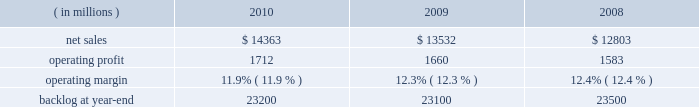Operating profit for the segment increased 10% ( 10 % ) in 2009 compared to 2008 .
The growth in operating profit primarily was due to increases in air mobility and other aeronautics programs .
The $ 70 million increase in air mobility 2019s operating profit primarily was due to the higher volume on c-130j deliveries and c-130 support programs .
In other aeronautics programs , operating profit increased $ 120 million , which mainly was attributable to improved performance in sustainment activities and higher volume on p-3 programs .
Additionally , the increase in operating profit included the favorable restructuring of a p-3 modification contract in 2009 .
Combat aircraft 2019s operating profit decreased $ 22 million during the year primarily due to a reduction in the level of favorable performance adjustments on f-16 programs in 2009 compared to 2008 and lower volume on other combat aircraft programs .
These decreases more than offset increased operating profit resulting from higher volume and improved performance on the f-35 program and an increase in the level of favorable performance adjustments on the f-22 program in 2009 compared to 2008 .
The remaining change in operating profit is attributable to a decrease in other income , net , between the comparable periods .
Backlog increased in 2010 compared to 2009 mainly due to orders exceeding sales on the c-130j , f-35 and c-5 programs , which partially were offset by higher sales volume compared to new orders on the f-22 program in 2010 .
Backlog decreased in 2009 compared to 2008 mainly due to sales exceeding orders on the f-22 and f-35 programs , which partially were offset by orders exceeding sales on the c-130j and c-5 programs .
We expect aeronautics will have sales growth in the upper single digit percentage range for 2011 as compared to 2010 .
This increase primarily is driven by growth on f-35 low rate initial production ( lrip ) contracts , c-130j and c-5 rerp programs that will more than offset a decline on the f-22 program .
Operating profit is projected to increase at a mid single digit percentage rate above 2010 levels , resulting in a decline in operating margins between the years .
Similar to the relationship of operating margins from 2009 to 2010 discussed above , the expected operating margin decrease from 2010 to 2011 reflects the trend of aeronautics performing more development and initial production work on the f-35 program and is performing less work on more mature programs such as the f-22 and f-16 , even though sales are expected to increase in 2011 relative to 2010 .
Electronic systems our electronic systems business segment manages complex programs and designs , develops , produces , and integrates hardware and software solutions to ensure the mission readiness of armed forces and government agencies worldwide .
The segment 2019s three lines of business are mission systems & sensors ( ms2 ) , missiles & fire control ( m&fc ) , and global training & logistics ( gt&l ) .
With such a broad portfolio of programs to provide products and services , many of its activities involve a combination of both development and production contracts with varying delivery schedules .
Some of its more significant programs , including the thaad system , the aegis weapon system , and the littoral combat ship program , demonstrate the diverse products and services electronic systems provides .
Electronic systems 2019 operating results included the following : ( in millions ) 2010 2009 2008 .
Net sales for electronic systems increased by 6% ( 6 % ) in 2010 compared to 2009 .
Sales increased in all three lines of business during the year .
The $ 421 million increase at gt&l primarily was due to growth on readiness and stability operations , which partially was offset by lower volume on simulation & training programs .
The $ 316 million increase at m&fc primarily was due to higher volume on tactical missile and air defense programs , which partially was offset by a decline in volume on fire control systems .
The $ 94 million increase at ms2 mainly was due to higher volume on surface naval warfare , ship & aviation systems , and radar systems programs , which partially was offset by lower volume on undersea warfare programs .
Net sales for electronic systems increased by 6% ( 6 % ) in 2009 compared to 2008 .
Sales increases in m&fc and gt&l more than offset a decline in ms2 .
The $ 429 million increase in sales at m&fc primarily was due to growth on tactical missile programs and fire control systems .
The $ 355 million increase at gt&l primarily was due to growth on simulation and training activities and readiness and stability operations .
The increase in simulation and training also included sales from the first quarter 2009 acquisition of universal systems and technology , inc .
The $ 55 million decrease at ms2 mainly was due to lower volume on ship & aviation systems and undersea warfare programs , which partially were offset by higher volume on radar systems and surface naval warfare programs. .
What were average net sales for electronic systems in millions from 2008 to 2010? 
Computations: table_average(net sales, none)
Answer: 13566.0. 